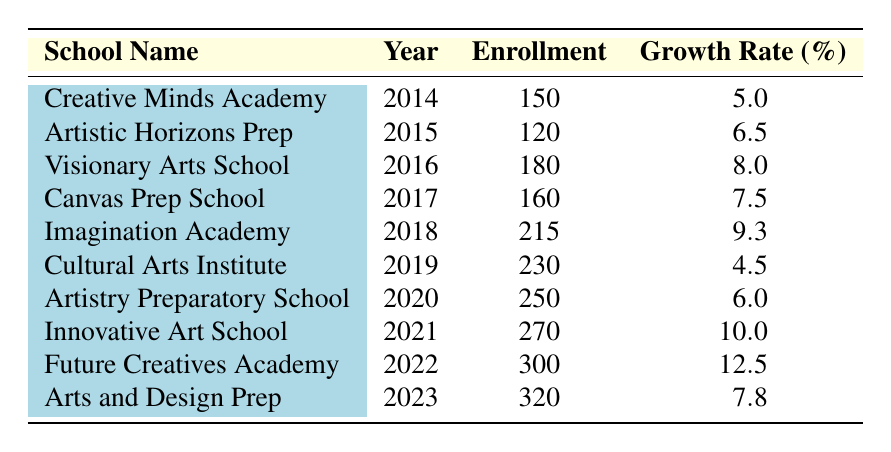What is the enrollment for Innovative Art School in 2021? From the table, I can directly see that the enrollment for Innovative Art School is listed under the corresponding year 2021 with a value of 270.
Answer: 270 Which school had the highest growth rate in 2022? According to the table, Future Creatives Academy experienced a growth rate of 12.5% in 2022, which is the highest among the listed schools for that year.
Answer: Future Creatives Academy What is the average growth rate for enrollment from 2014 to 2023? The growth rates from 2014 to 2023 are 5.0, 6.5, 8.0, 7.5, 9.3, 4.5, 6.0, 10.0, 12.5, and 7.8. Adding these rates gives a total of 69.1. Dividing by 10 (the number of years) results in an average growth rate of 6.91%.
Answer: 6.91% Is the enrollment for Canvas Prep School greater than 200? Looking at the table, the enrollment for Canvas Prep School in 2017 is 160, which is not greater than 200.
Answer: No What was the total enrollment for all schools combined in 2019? Referring to the table, I can find the enrollment for Cultural Arts Institute in 2019, which is 230. Therefore, total enrollment is just 230 as it's the only value shown for that year.
Answer: 230 Which school had a growth rate of 10.0% in 2021? The table specifies that Innovative Art School had a growth rate of 10.0% in 2021. This is explicitly stated in the row corresponding to that year and school.
Answer: Innovative Art School What is the difference in enrollment between Future Creatives Academy in 2022 and Arts and Design Prep in 2023? Future Creatives Academy had an enrollment of 300 in 2022, while Arts and Design Prep had an enrollment of 320 in 2023. The difference is calculated as 320 - 300 = 20.
Answer: 20 What was the enrollment trend from 2014 to 2023? Reviewing the enrollment figures from the table, the enrollment has generally increased over the years, moving from 150 in 2014 to 320 in 2023, indicating a positive growth trend throughout the decade.
Answer: Increasing trend 